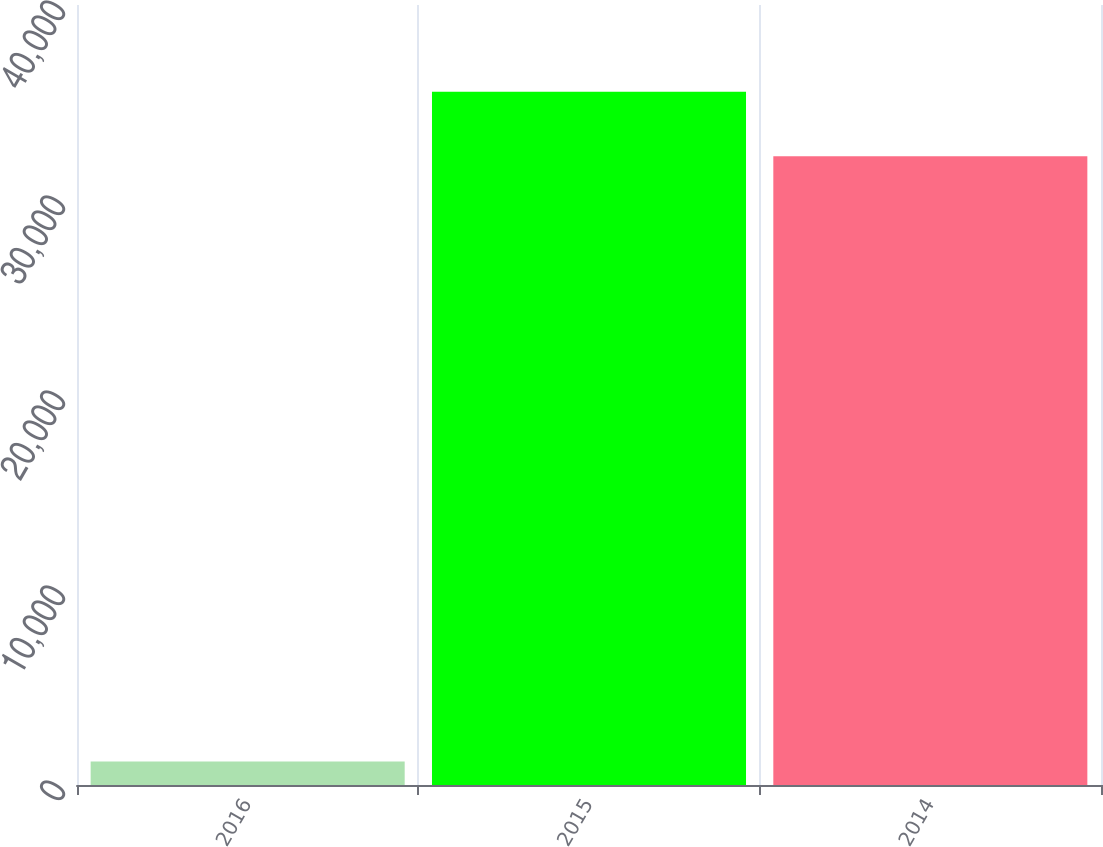<chart> <loc_0><loc_0><loc_500><loc_500><bar_chart><fcel>2016<fcel>2015<fcel>2014<nl><fcel>1211<fcel>35548.5<fcel>32247<nl></chart> 